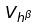<formula> <loc_0><loc_0><loc_500><loc_500>V _ { h ^ { \beta } }</formula> 